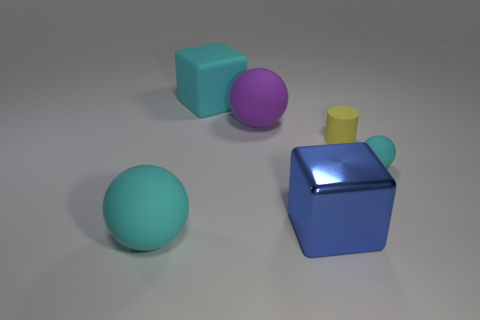Is there a yellow rubber object that has the same shape as the purple rubber object?
Make the answer very short. No. The thing that is the same size as the cylinder is what shape?
Your answer should be compact. Sphere. How many objects are either cyan things behind the small cyan matte object or big cyan matte spheres?
Provide a short and direct response. 2. Do the small rubber cylinder and the metallic cube have the same color?
Provide a short and direct response. No. There is a rubber sphere to the right of the purple sphere; what size is it?
Ensure brevity in your answer.  Small. Is there a blue shiny object of the same size as the matte cube?
Ensure brevity in your answer.  Yes. Is the size of the cube to the left of the blue object the same as the purple sphere?
Your answer should be very brief. Yes. The cylinder is what size?
Offer a terse response. Small. What color is the large sphere that is on the right side of the object that is to the left of the big block that is behind the blue block?
Your answer should be compact. Purple. There is a big block in front of the tiny rubber cylinder; is its color the same as the matte block?
Give a very brief answer. No. 